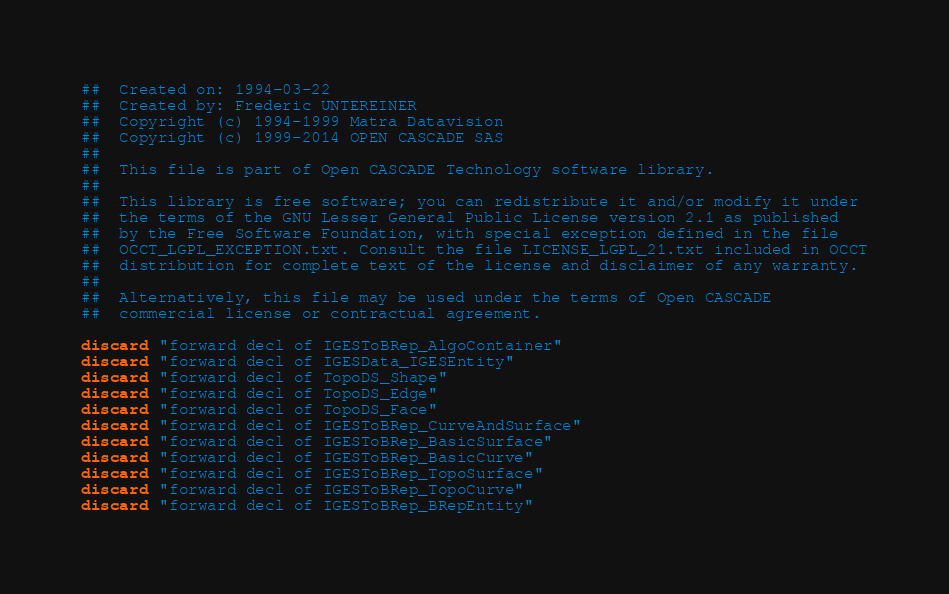<code> <loc_0><loc_0><loc_500><loc_500><_Nim_>##  Created on: 1994-03-22
##  Created by: Frederic UNTEREINER
##  Copyright (c) 1994-1999 Matra Datavision
##  Copyright (c) 1999-2014 OPEN CASCADE SAS
##
##  This file is part of Open CASCADE Technology software library.
##
##  This library is free software; you can redistribute it and/or modify it under
##  the terms of the GNU Lesser General Public License version 2.1 as published
##  by the Free Software Foundation, with special exception defined in the file
##  OCCT_LGPL_EXCEPTION.txt. Consult the file LICENSE_LGPL_21.txt included in OCCT
##  distribution for complete text of the license and disclaimer of any warranty.
##
##  Alternatively, this file may be used under the terms of Open CASCADE
##  commercial license or contractual agreement.

discard "forward decl of IGESToBRep_AlgoContainer"
discard "forward decl of IGESData_IGESEntity"
discard "forward decl of TopoDS_Shape"
discard "forward decl of TopoDS_Edge"
discard "forward decl of TopoDS_Face"
discard "forward decl of IGESToBRep_CurveAndSurface"
discard "forward decl of IGESToBRep_BasicSurface"
discard "forward decl of IGESToBRep_BasicCurve"
discard "forward decl of IGESToBRep_TopoSurface"
discard "forward decl of IGESToBRep_TopoCurve"
discard "forward decl of IGESToBRep_BRepEntity"</code> 